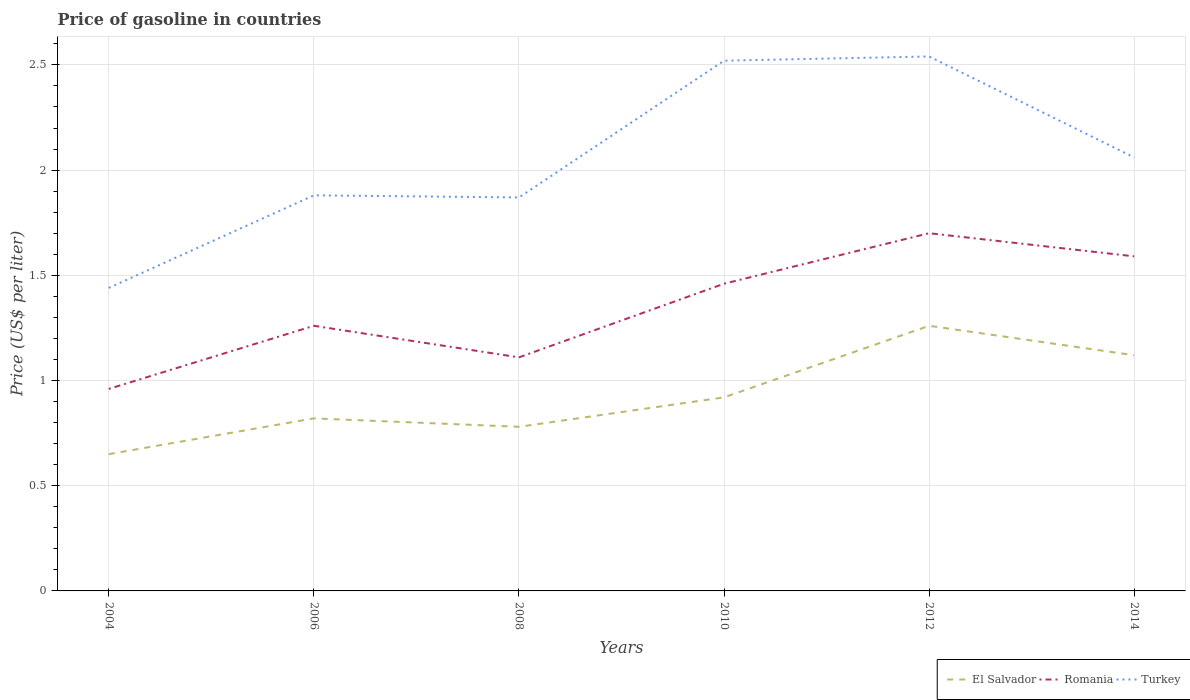How many different coloured lines are there?
Offer a very short reply. 3. Does the line corresponding to El Salvador intersect with the line corresponding to Turkey?
Your answer should be compact. No. What is the total price of gasoline in El Salvador in the graph?
Provide a succinct answer. -0.27. How many lines are there?
Your response must be concise. 3. What is the difference between two consecutive major ticks on the Y-axis?
Offer a terse response. 0.5. Where does the legend appear in the graph?
Your response must be concise. Bottom right. What is the title of the graph?
Offer a terse response. Price of gasoline in countries. What is the label or title of the X-axis?
Your answer should be compact. Years. What is the label or title of the Y-axis?
Ensure brevity in your answer.  Price (US$ per liter). What is the Price (US$ per liter) in El Salvador in 2004?
Ensure brevity in your answer.  0.65. What is the Price (US$ per liter) of Romania in 2004?
Your answer should be very brief. 0.96. What is the Price (US$ per liter) of Turkey in 2004?
Ensure brevity in your answer.  1.44. What is the Price (US$ per liter) in El Salvador in 2006?
Ensure brevity in your answer.  0.82. What is the Price (US$ per liter) in Romania in 2006?
Your answer should be compact. 1.26. What is the Price (US$ per liter) in Turkey in 2006?
Offer a terse response. 1.88. What is the Price (US$ per liter) of El Salvador in 2008?
Provide a succinct answer. 0.78. What is the Price (US$ per liter) of Romania in 2008?
Give a very brief answer. 1.11. What is the Price (US$ per liter) of Turkey in 2008?
Provide a short and direct response. 1.87. What is the Price (US$ per liter) of Romania in 2010?
Your answer should be compact. 1.46. What is the Price (US$ per liter) of Turkey in 2010?
Provide a succinct answer. 2.52. What is the Price (US$ per liter) in El Salvador in 2012?
Your answer should be very brief. 1.26. What is the Price (US$ per liter) of Turkey in 2012?
Ensure brevity in your answer.  2.54. What is the Price (US$ per liter) of El Salvador in 2014?
Your answer should be very brief. 1.12. What is the Price (US$ per liter) in Romania in 2014?
Offer a very short reply. 1.59. What is the Price (US$ per liter) of Turkey in 2014?
Provide a short and direct response. 2.06. Across all years, what is the maximum Price (US$ per liter) of El Salvador?
Offer a very short reply. 1.26. Across all years, what is the maximum Price (US$ per liter) of Turkey?
Provide a short and direct response. 2.54. Across all years, what is the minimum Price (US$ per liter) in El Salvador?
Offer a terse response. 0.65. Across all years, what is the minimum Price (US$ per liter) in Romania?
Provide a succinct answer. 0.96. Across all years, what is the minimum Price (US$ per liter) in Turkey?
Provide a short and direct response. 1.44. What is the total Price (US$ per liter) of El Salvador in the graph?
Ensure brevity in your answer.  5.55. What is the total Price (US$ per liter) in Romania in the graph?
Ensure brevity in your answer.  8.08. What is the total Price (US$ per liter) of Turkey in the graph?
Ensure brevity in your answer.  12.31. What is the difference between the Price (US$ per liter) in El Salvador in 2004 and that in 2006?
Your response must be concise. -0.17. What is the difference between the Price (US$ per liter) of Turkey in 2004 and that in 2006?
Your answer should be compact. -0.44. What is the difference between the Price (US$ per liter) of El Salvador in 2004 and that in 2008?
Offer a terse response. -0.13. What is the difference between the Price (US$ per liter) of Turkey in 2004 and that in 2008?
Your answer should be very brief. -0.43. What is the difference between the Price (US$ per liter) in El Salvador in 2004 and that in 2010?
Provide a short and direct response. -0.27. What is the difference between the Price (US$ per liter) of Romania in 2004 and that in 2010?
Offer a terse response. -0.5. What is the difference between the Price (US$ per liter) in Turkey in 2004 and that in 2010?
Ensure brevity in your answer.  -1.08. What is the difference between the Price (US$ per liter) in El Salvador in 2004 and that in 2012?
Your answer should be very brief. -0.61. What is the difference between the Price (US$ per liter) of Romania in 2004 and that in 2012?
Offer a terse response. -0.74. What is the difference between the Price (US$ per liter) in Turkey in 2004 and that in 2012?
Your answer should be compact. -1.1. What is the difference between the Price (US$ per liter) in El Salvador in 2004 and that in 2014?
Provide a short and direct response. -0.47. What is the difference between the Price (US$ per liter) in Romania in 2004 and that in 2014?
Make the answer very short. -0.63. What is the difference between the Price (US$ per liter) in Turkey in 2004 and that in 2014?
Provide a short and direct response. -0.62. What is the difference between the Price (US$ per liter) in Romania in 2006 and that in 2008?
Your answer should be compact. 0.15. What is the difference between the Price (US$ per liter) of Turkey in 2006 and that in 2008?
Your response must be concise. 0.01. What is the difference between the Price (US$ per liter) of Romania in 2006 and that in 2010?
Provide a short and direct response. -0.2. What is the difference between the Price (US$ per liter) of Turkey in 2006 and that in 2010?
Your answer should be compact. -0.64. What is the difference between the Price (US$ per liter) of El Salvador in 2006 and that in 2012?
Your answer should be compact. -0.44. What is the difference between the Price (US$ per liter) of Romania in 2006 and that in 2012?
Your answer should be compact. -0.44. What is the difference between the Price (US$ per liter) of Turkey in 2006 and that in 2012?
Your answer should be very brief. -0.66. What is the difference between the Price (US$ per liter) of Romania in 2006 and that in 2014?
Give a very brief answer. -0.33. What is the difference between the Price (US$ per liter) of Turkey in 2006 and that in 2014?
Provide a succinct answer. -0.18. What is the difference between the Price (US$ per liter) in El Salvador in 2008 and that in 2010?
Your answer should be compact. -0.14. What is the difference between the Price (US$ per liter) in Romania in 2008 and that in 2010?
Provide a succinct answer. -0.35. What is the difference between the Price (US$ per liter) in Turkey in 2008 and that in 2010?
Keep it short and to the point. -0.65. What is the difference between the Price (US$ per liter) of El Salvador in 2008 and that in 2012?
Provide a short and direct response. -0.48. What is the difference between the Price (US$ per liter) in Romania in 2008 and that in 2012?
Your response must be concise. -0.59. What is the difference between the Price (US$ per liter) of Turkey in 2008 and that in 2012?
Offer a terse response. -0.67. What is the difference between the Price (US$ per liter) in El Salvador in 2008 and that in 2014?
Provide a succinct answer. -0.34. What is the difference between the Price (US$ per liter) of Romania in 2008 and that in 2014?
Your response must be concise. -0.48. What is the difference between the Price (US$ per liter) in Turkey in 2008 and that in 2014?
Offer a terse response. -0.19. What is the difference between the Price (US$ per liter) of El Salvador in 2010 and that in 2012?
Your response must be concise. -0.34. What is the difference between the Price (US$ per liter) of Romania in 2010 and that in 2012?
Make the answer very short. -0.24. What is the difference between the Price (US$ per liter) in Turkey in 2010 and that in 2012?
Give a very brief answer. -0.02. What is the difference between the Price (US$ per liter) of El Salvador in 2010 and that in 2014?
Provide a succinct answer. -0.2. What is the difference between the Price (US$ per liter) in Romania in 2010 and that in 2014?
Your answer should be very brief. -0.13. What is the difference between the Price (US$ per liter) in Turkey in 2010 and that in 2014?
Ensure brevity in your answer.  0.46. What is the difference between the Price (US$ per liter) of El Salvador in 2012 and that in 2014?
Your answer should be very brief. 0.14. What is the difference between the Price (US$ per liter) of Romania in 2012 and that in 2014?
Your response must be concise. 0.11. What is the difference between the Price (US$ per liter) in Turkey in 2012 and that in 2014?
Give a very brief answer. 0.48. What is the difference between the Price (US$ per liter) in El Salvador in 2004 and the Price (US$ per liter) in Romania in 2006?
Offer a terse response. -0.61. What is the difference between the Price (US$ per liter) in El Salvador in 2004 and the Price (US$ per liter) in Turkey in 2006?
Offer a terse response. -1.23. What is the difference between the Price (US$ per liter) in Romania in 2004 and the Price (US$ per liter) in Turkey in 2006?
Offer a terse response. -0.92. What is the difference between the Price (US$ per liter) of El Salvador in 2004 and the Price (US$ per liter) of Romania in 2008?
Your response must be concise. -0.46. What is the difference between the Price (US$ per liter) in El Salvador in 2004 and the Price (US$ per liter) in Turkey in 2008?
Offer a terse response. -1.22. What is the difference between the Price (US$ per liter) in Romania in 2004 and the Price (US$ per liter) in Turkey in 2008?
Make the answer very short. -0.91. What is the difference between the Price (US$ per liter) of El Salvador in 2004 and the Price (US$ per liter) of Romania in 2010?
Your response must be concise. -0.81. What is the difference between the Price (US$ per liter) of El Salvador in 2004 and the Price (US$ per liter) of Turkey in 2010?
Offer a very short reply. -1.87. What is the difference between the Price (US$ per liter) in Romania in 2004 and the Price (US$ per liter) in Turkey in 2010?
Give a very brief answer. -1.56. What is the difference between the Price (US$ per liter) in El Salvador in 2004 and the Price (US$ per liter) in Romania in 2012?
Provide a short and direct response. -1.05. What is the difference between the Price (US$ per liter) in El Salvador in 2004 and the Price (US$ per liter) in Turkey in 2012?
Your answer should be very brief. -1.89. What is the difference between the Price (US$ per liter) of Romania in 2004 and the Price (US$ per liter) of Turkey in 2012?
Provide a succinct answer. -1.58. What is the difference between the Price (US$ per liter) of El Salvador in 2004 and the Price (US$ per liter) of Romania in 2014?
Ensure brevity in your answer.  -0.94. What is the difference between the Price (US$ per liter) of El Salvador in 2004 and the Price (US$ per liter) of Turkey in 2014?
Your answer should be very brief. -1.41. What is the difference between the Price (US$ per liter) of El Salvador in 2006 and the Price (US$ per liter) of Romania in 2008?
Your answer should be very brief. -0.29. What is the difference between the Price (US$ per liter) of El Salvador in 2006 and the Price (US$ per liter) of Turkey in 2008?
Offer a terse response. -1.05. What is the difference between the Price (US$ per liter) in Romania in 2006 and the Price (US$ per liter) in Turkey in 2008?
Your answer should be compact. -0.61. What is the difference between the Price (US$ per liter) of El Salvador in 2006 and the Price (US$ per liter) of Romania in 2010?
Your response must be concise. -0.64. What is the difference between the Price (US$ per liter) of El Salvador in 2006 and the Price (US$ per liter) of Turkey in 2010?
Offer a terse response. -1.7. What is the difference between the Price (US$ per liter) of Romania in 2006 and the Price (US$ per liter) of Turkey in 2010?
Your answer should be compact. -1.26. What is the difference between the Price (US$ per liter) of El Salvador in 2006 and the Price (US$ per liter) of Romania in 2012?
Provide a short and direct response. -0.88. What is the difference between the Price (US$ per liter) of El Salvador in 2006 and the Price (US$ per liter) of Turkey in 2012?
Offer a very short reply. -1.72. What is the difference between the Price (US$ per liter) in Romania in 2006 and the Price (US$ per liter) in Turkey in 2012?
Your answer should be compact. -1.28. What is the difference between the Price (US$ per liter) of El Salvador in 2006 and the Price (US$ per liter) of Romania in 2014?
Make the answer very short. -0.77. What is the difference between the Price (US$ per liter) in El Salvador in 2006 and the Price (US$ per liter) in Turkey in 2014?
Provide a succinct answer. -1.24. What is the difference between the Price (US$ per liter) in El Salvador in 2008 and the Price (US$ per liter) in Romania in 2010?
Your response must be concise. -0.68. What is the difference between the Price (US$ per liter) in El Salvador in 2008 and the Price (US$ per liter) in Turkey in 2010?
Provide a succinct answer. -1.74. What is the difference between the Price (US$ per liter) in Romania in 2008 and the Price (US$ per liter) in Turkey in 2010?
Your answer should be very brief. -1.41. What is the difference between the Price (US$ per liter) in El Salvador in 2008 and the Price (US$ per liter) in Romania in 2012?
Provide a succinct answer. -0.92. What is the difference between the Price (US$ per liter) of El Salvador in 2008 and the Price (US$ per liter) of Turkey in 2012?
Give a very brief answer. -1.76. What is the difference between the Price (US$ per liter) of Romania in 2008 and the Price (US$ per liter) of Turkey in 2012?
Offer a terse response. -1.43. What is the difference between the Price (US$ per liter) in El Salvador in 2008 and the Price (US$ per liter) in Romania in 2014?
Offer a very short reply. -0.81. What is the difference between the Price (US$ per liter) of El Salvador in 2008 and the Price (US$ per liter) of Turkey in 2014?
Keep it short and to the point. -1.28. What is the difference between the Price (US$ per liter) of Romania in 2008 and the Price (US$ per liter) of Turkey in 2014?
Ensure brevity in your answer.  -0.95. What is the difference between the Price (US$ per liter) in El Salvador in 2010 and the Price (US$ per liter) in Romania in 2012?
Provide a succinct answer. -0.78. What is the difference between the Price (US$ per liter) of El Salvador in 2010 and the Price (US$ per liter) of Turkey in 2012?
Ensure brevity in your answer.  -1.62. What is the difference between the Price (US$ per liter) of Romania in 2010 and the Price (US$ per liter) of Turkey in 2012?
Ensure brevity in your answer.  -1.08. What is the difference between the Price (US$ per liter) in El Salvador in 2010 and the Price (US$ per liter) in Romania in 2014?
Your answer should be very brief. -0.67. What is the difference between the Price (US$ per liter) of El Salvador in 2010 and the Price (US$ per liter) of Turkey in 2014?
Provide a succinct answer. -1.14. What is the difference between the Price (US$ per liter) in Romania in 2010 and the Price (US$ per liter) in Turkey in 2014?
Ensure brevity in your answer.  -0.6. What is the difference between the Price (US$ per liter) of El Salvador in 2012 and the Price (US$ per liter) of Romania in 2014?
Your answer should be very brief. -0.33. What is the difference between the Price (US$ per liter) of El Salvador in 2012 and the Price (US$ per liter) of Turkey in 2014?
Provide a succinct answer. -0.8. What is the difference between the Price (US$ per liter) in Romania in 2012 and the Price (US$ per liter) in Turkey in 2014?
Your response must be concise. -0.36. What is the average Price (US$ per liter) of El Salvador per year?
Your response must be concise. 0.93. What is the average Price (US$ per liter) of Romania per year?
Give a very brief answer. 1.35. What is the average Price (US$ per liter) of Turkey per year?
Ensure brevity in your answer.  2.05. In the year 2004, what is the difference between the Price (US$ per liter) in El Salvador and Price (US$ per liter) in Romania?
Make the answer very short. -0.31. In the year 2004, what is the difference between the Price (US$ per liter) in El Salvador and Price (US$ per liter) in Turkey?
Keep it short and to the point. -0.79. In the year 2004, what is the difference between the Price (US$ per liter) in Romania and Price (US$ per liter) in Turkey?
Offer a very short reply. -0.48. In the year 2006, what is the difference between the Price (US$ per liter) of El Salvador and Price (US$ per liter) of Romania?
Make the answer very short. -0.44. In the year 2006, what is the difference between the Price (US$ per liter) in El Salvador and Price (US$ per liter) in Turkey?
Provide a short and direct response. -1.06. In the year 2006, what is the difference between the Price (US$ per liter) in Romania and Price (US$ per liter) in Turkey?
Give a very brief answer. -0.62. In the year 2008, what is the difference between the Price (US$ per liter) in El Salvador and Price (US$ per liter) in Romania?
Ensure brevity in your answer.  -0.33. In the year 2008, what is the difference between the Price (US$ per liter) in El Salvador and Price (US$ per liter) in Turkey?
Make the answer very short. -1.09. In the year 2008, what is the difference between the Price (US$ per liter) in Romania and Price (US$ per liter) in Turkey?
Provide a succinct answer. -0.76. In the year 2010, what is the difference between the Price (US$ per liter) in El Salvador and Price (US$ per liter) in Romania?
Your answer should be very brief. -0.54. In the year 2010, what is the difference between the Price (US$ per liter) in El Salvador and Price (US$ per liter) in Turkey?
Keep it short and to the point. -1.6. In the year 2010, what is the difference between the Price (US$ per liter) in Romania and Price (US$ per liter) in Turkey?
Ensure brevity in your answer.  -1.06. In the year 2012, what is the difference between the Price (US$ per liter) in El Salvador and Price (US$ per liter) in Romania?
Provide a short and direct response. -0.44. In the year 2012, what is the difference between the Price (US$ per liter) of El Salvador and Price (US$ per liter) of Turkey?
Keep it short and to the point. -1.28. In the year 2012, what is the difference between the Price (US$ per liter) in Romania and Price (US$ per liter) in Turkey?
Your answer should be compact. -0.84. In the year 2014, what is the difference between the Price (US$ per liter) of El Salvador and Price (US$ per liter) of Romania?
Provide a succinct answer. -0.47. In the year 2014, what is the difference between the Price (US$ per liter) of El Salvador and Price (US$ per liter) of Turkey?
Offer a very short reply. -0.94. In the year 2014, what is the difference between the Price (US$ per liter) in Romania and Price (US$ per liter) in Turkey?
Offer a terse response. -0.47. What is the ratio of the Price (US$ per liter) of El Salvador in 2004 to that in 2006?
Make the answer very short. 0.79. What is the ratio of the Price (US$ per liter) of Romania in 2004 to that in 2006?
Your answer should be very brief. 0.76. What is the ratio of the Price (US$ per liter) of Turkey in 2004 to that in 2006?
Provide a short and direct response. 0.77. What is the ratio of the Price (US$ per liter) of El Salvador in 2004 to that in 2008?
Keep it short and to the point. 0.83. What is the ratio of the Price (US$ per liter) of Romania in 2004 to that in 2008?
Keep it short and to the point. 0.86. What is the ratio of the Price (US$ per liter) in Turkey in 2004 to that in 2008?
Your answer should be compact. 0.77. What is the ratio of the Price (US$ per liter) in El Salvador in 2004 to that in 2010?
Your answer should be compact. 0.71. What is the ratio of the Price (US$ per liter) of Romania in 2004 to that in 2010?
Keep it short and to the point. 0.66. What is the ratio of the Price (US$ per liter) of Turkey in 2004 to that in 2010?
Keep it short and to the point. 0.57. What is the ratio of the Price (US$ per liter) in El Salvador in 2004 to that in 2012?
Offer a terse response. 0.52. What is the ratio of the Price (US$ per liter) of Romania in 2004 to that in 2012?
Your response must be concise. 0.56. What is the ratio of the Price (US$ per liter) of Turkey in 2004 to that in 2012?
Make the answer very short. 0.57. What is the ratio of the Price (US$ per liter) of El Salvador in 2004 to that in 2014?
Your answer should be compact. 0.58. What is the ratio of the Price (US$ per liter) of Romania in 2004 to that in 2014?
Keep it short and to the point. 0.6. What is the ratio of the Price (US$ per liter) in Turkey in 2004 to that in 2014?
Your response must be concise. 0.7. What is the ratio of the Price (US$ per liter) of El Salvador in 2006 to that in 2008?
Provide a succinct answer. 1.05. What is the ratio of the Price (US$ per liter) in Romania in 2006 to that in 2008?
Your answer should be compact. 1.14. What is the ratio of the Price (US$ per liter) of El Salvador in 2006 to that in 2010?
Keep it short and to the point. 0.89. What is the ratio of the Price (US$ per liter) in Romania in 2006 to that in 2010?
Provide a short and direct response. 0.86. What is the ratio of the Price (US$ per liter) in Turkey in 2006 to that in 2010?
Provide a succinct answer. 0.75. What is the ratio of the Price (US$ per liter) of El Salvador in 2006 to that in 2012?
Make the answer very short. 0.65. What is the ratio of the Price (US$ per liter) of Romania in 2006 to that in 2012?
Provide a short and direct response. 0.74. What is the ratio of the Price (US$ per liter) of Turkey in 2006 to that in 2012?
Provide a short and direct response. 0.74. What is the ratio of the Price (US$ per liter) in El Salvador in 2006 to that in 2014?
Your response must be concise. 0.73. What is the ratio of the Price (US$ per liter) of Romania in 2006 to that in 2014?
Provide a succinct answer. 0.79. What is the ratio of the Price (US$ per liter) in Turkey in 2006 to that in 2014?
Your answer should be very brief. 0.91. What is the ratio of the Price (US$ per liter) in El Salvador in 2008 to that in 2010?
Your answer should be compact. 0.85. What is the ratio of the Price (US$ per liter) of Romania in 2008 to that in 2010?
Provide a short and direct response. 0.76. What is the ratio of the Price (US$ per liter) of Turkey in 2008 to that in 2010?
Offer a terse response. 0.74. What is the ratio of the Price (US$ per liter) in El Salvador in 2008 to that in 2012?
Your answer should be compact. 0.62. What is the ratio of the Price (US$ per liter) of Romania in 2008 to that in 2012?
Give a very brief answer. 0.65. What is the ratio of the Price (US$ per liter) of Turkey in 2008 to that in 2012?
Provide a short and direct response. 0.74. What is the ratio of the Price (US$ per liter) in El Salvador in 2008 to that in 2014?
Your answer should be very brief. 0.7. What is the ratio of the Price (US$ per liter) in Romania in 2008 to that in 2014?
Give a very brief answer. 0.7. What is the ratio of the Price (US$ per liter) of Turkey in 2008 to that in 2014?
Your answer should be compact. 0.91. What is the ratio of the Price (US$ per liter) in El Salvador in 2010 to that in 2012?
Provide a succinct answer. 0.73. What is the ratio of the Price (US$ per liter) in Romania in 2010 to that in 2012?
Provide a succinct answer. 0.86. What is the ratio of the Price (US$ per liter) of El Salvador in 2010 to that in 2014?
Give a very brief answer. 0.82. What is the ratio of the Price (US$ per liter) of Romania in 2010 to that in 2014?
Your answer should be very brief. 0.92. What is the ratio of the Price (US$ per liter) of Turkey in 2010 to that in 2014?
Your response must be concise. 1.22. What is the ratio of the Price (US$ per liter) in Romania in 2012 to that in 2014?
Your answer should be compact. 1.07. What is the ratio of the Price (US$ per liter) of Turkey in 2012 to that in 2014?
Ensure brevity in your answer.  1.23. What is the difference between the highest and the second highest Price (US$ per liter) of El Salvador?
Ensure brevity in your answer.  0.14. What is the difference between the highest and the second highest Price (US$ per liter) in Romania?
Give a very brief answer. 0.11. What is the difference between the highest and the second highest Price (US$ per liter) of Turkey?
Provide a short and direct response. 0.02. What is the difference between the highest and the lowest Price (US$ per liter) in El Salvador?
Keep it short and to the point. 0.61. What is the difference between the highest and the lowest Price (US$ per liter) of Romania?
Offer a very short reply. 0.74. What is the difference between the highest and the lowest Price (US$ per liter) of Turkey?
Offer a terse response. 1.1. 